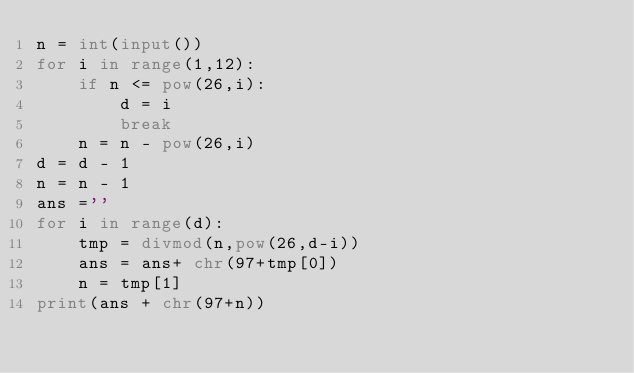Convert code to text. <code><loc_0><loc_0><loc_500><loc_500><_Python_>n = int(input())
for i in range(1,12):
    if n <= pow(26,i):
        d = i
        break
    n = n - pow(26,i)
d = d - 1 
n = n - 1
ans =''
for i in range(d):
    tmp = divmod(n,pow(26,d-i))
    ans = ans+ chr(97+tmp[0])
    n = tmp[1]
print(ans + chr(97+n))</code> 